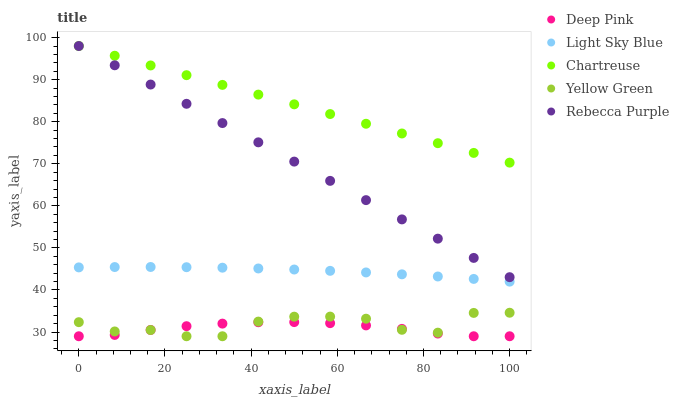Does Deep Pink have the minimum area under the curve?
Answer yes or no. Yes. Does Chartreuse have the maximum area under the curve?
Answer yes or no. Yes. Does Yellow Green have the minimum area under the curve?
Answer yes or no. No. Does Yellow Green have the maximum area under the curve?
Answer yes or no. No. Is Chartreuse the smoothest?
Answer yes or no. Yes. Is Yellow Green the roughest?
Answer yes or no. Yes. Is Deep Pink the smoothest?
Answer yes or no. No. Is Deep Pink the roughest?
Answer yes or no. No. Does Deep Pink have the lowest value?
Answer yes or no. Yes. Does Light Sky Blue have the lowest value?
Answer yes or no. No. Does Rebecca Purple have the highest value?
Answer yes or no. Yes. Does Yellow Green have the highest value?
Answer yes or no. No. Is Yellow Green less than Rebecca Purple?
Answer yes or no. Yes. Is Chartreuse greater than Light Sky Blue?
Answer yes or no. Yes. Does Yellow Green intersect Deep Pink?
Answer yes or no. Yes. Is Yellow Green less than Deep Pink?
Answer yes or no. No. Is Yellow Green greater than Deep Pink?
Answer yes or no. No. Does Yellow Green intersect Rebecca Purple?
Answer yes or no. No. 